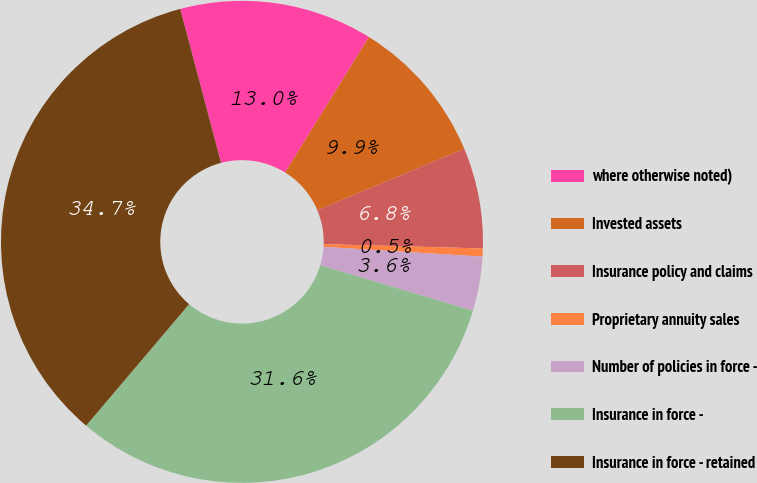<chart> <loc_0><loc_0><loc_500><loc_500><pie_chart><fcel>where otherwise noted)<fcel>Invested assets<fcel>Insurance policy and claims<fcel>Proprietary annuity sales<fcel>Number of policies in force -<fcel>Insurance in force -<fcel>Insurance in force - retained<nl><fcel>12.96%<fcel>9.85%<fcel>6.75%<fcel>0.54%<fcel>3.64%<fcel>31.58%<fcel>34.68%<nl></chart> 